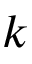Convert formula to latex. <formula><loc_0><loc_0><loc_500><loc_500>k</formula> 